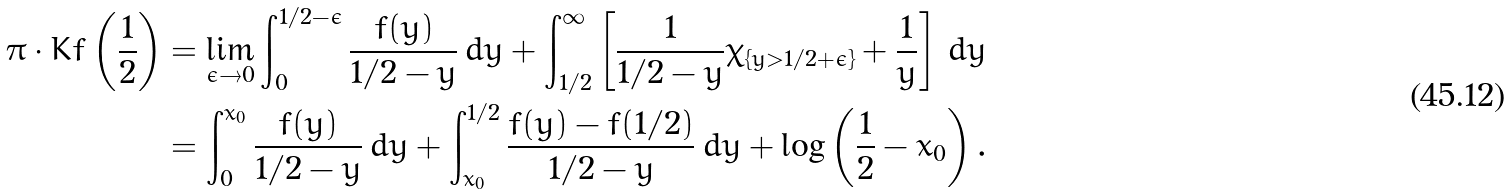<formula> <loc_0><loc_0><loc_500><loc_500>\pi \cdot K f \left ( \frac { 1 } { 2 } \right ) & = \lim _ { \epsilon \to 0 } \int _ { 0 } ^ { 1 / 2 - \epsilon } \frac { f ( y ) } { 1 / 2 - y } \, d y + \int _ { 1 / 2 } ^ { \infty } \left [ \frac { 1 } { 1 / 2 - y } \chi _ { \{ y > 1 / 2 + \epsilon \} } + \frac { 1 } { y } \right ] \, d y \\ & = \int _ { 0 } ^ { x _ { 0 } } \frac { f ( y ) } { 1 / 2 - y } \, d y + \int _ { x _ { 0 } } ^ { 1 / 2 } \frac { f ( y ) - f ( 1 / 2 ) } { 1 / 2 - y } \, d y + \log \left ( \frac { 1 } { 2 } - x _ { 0 } \right ) .</formula> 